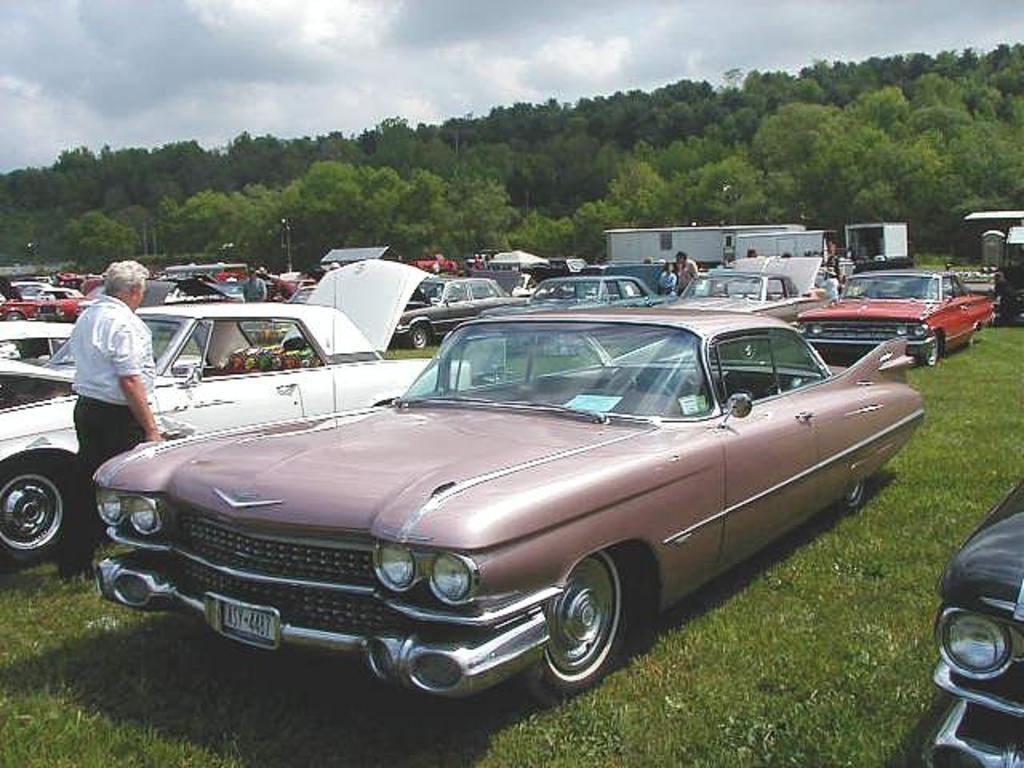What is the main subject of the image? There are many cars in the image. Where was the image taken? The image was taken outside. What can be seen in the middle of the image besides the cars? There are trees in the middle of the image. What is visible at the top of the image? The sky is visible at the top of the image. Can you describe the man on the left side of the image? There is a man on the left side of the image. What type of linen is draped over the cars in the image? There is no linen present in the image; it features many cars, trees, the sky, and a man on the left side. Can you tell me how many frogs are hopping around the cars in the image? There are no frogs present in the image; it features many cars, trees, the sky, and a man on the left side. 